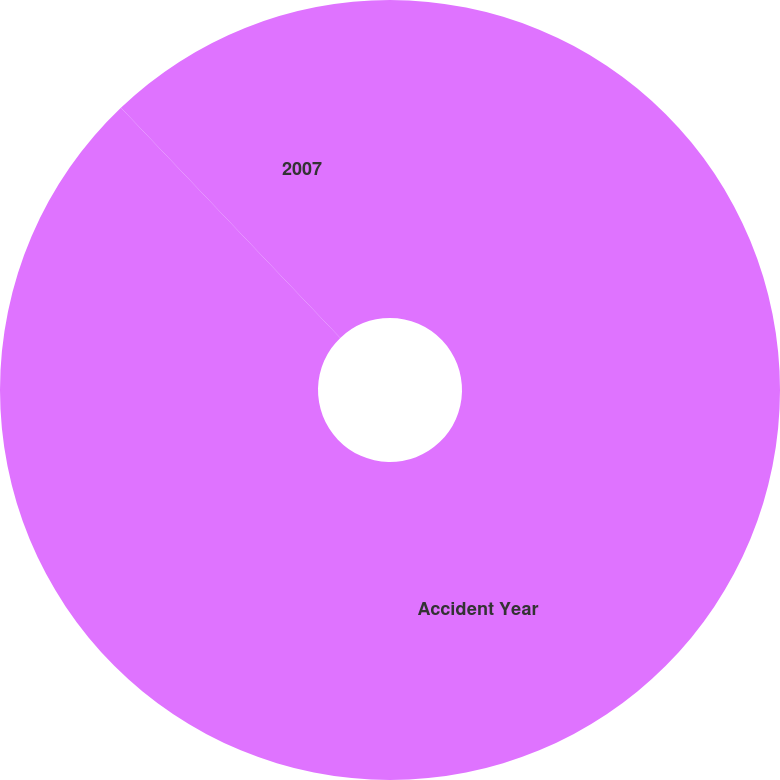<chart> <loc_0><loc_0><loc_500><loc_500><pie_chart><fcel>Accident Year<fcel>2007<nl><fcel>87.88%<fcel>12.12%<nl></chart> 